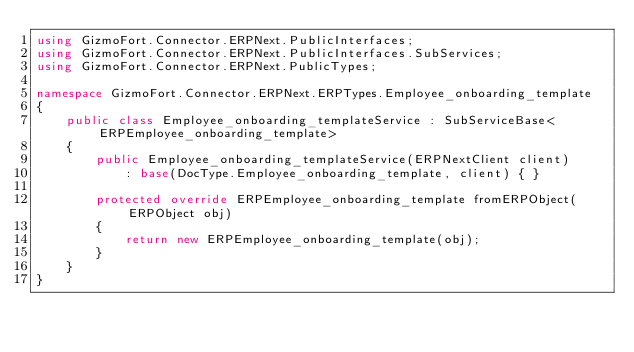<code> <loc_0><loc_0><loc_500><loc_500><_C#_>using GizmoFort.Connector.ERPNext.PublicInterfaces;
using GizmoFort.Connector.ERPNext.PublicInterfaces.SubServices;
using GizmoFort.Connector.ERPNext.PublicTypes;

namespace GizmoFort.Connector.ERPNext.ERPTypes.Employee_onboarding_template
{
    public class Employee_onboarding_templateService : SubServiceBase<ERPEmployee_onboarding_template>
    {
        public Employee_onboarding_templateService(ERPNextClient client)
            : base(DocType.Employee_onboarding_template, client) { }

        protected override ERPEmployee_onboarding_template fromERPObject(ERPObject obj)
        {
            return new ERPEmployee_onboarding_template(obj);
        }
    }
}</code> 